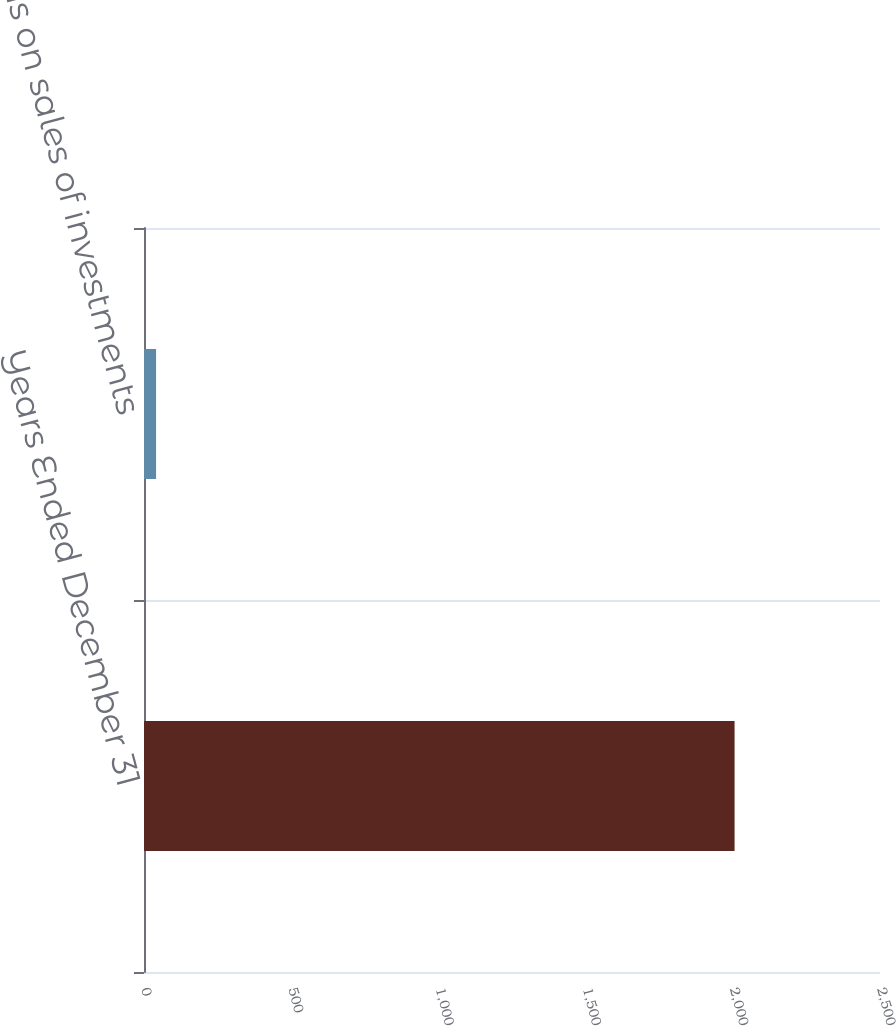Convert chart to OTSL. <chart><loc_0><loc_0><loc_500><loc_500><bar_chart><fcel>Years Ended December 31<fcel>Gains on sales of investments<nl><fcel>2006<fcel>41<nl></chart> 